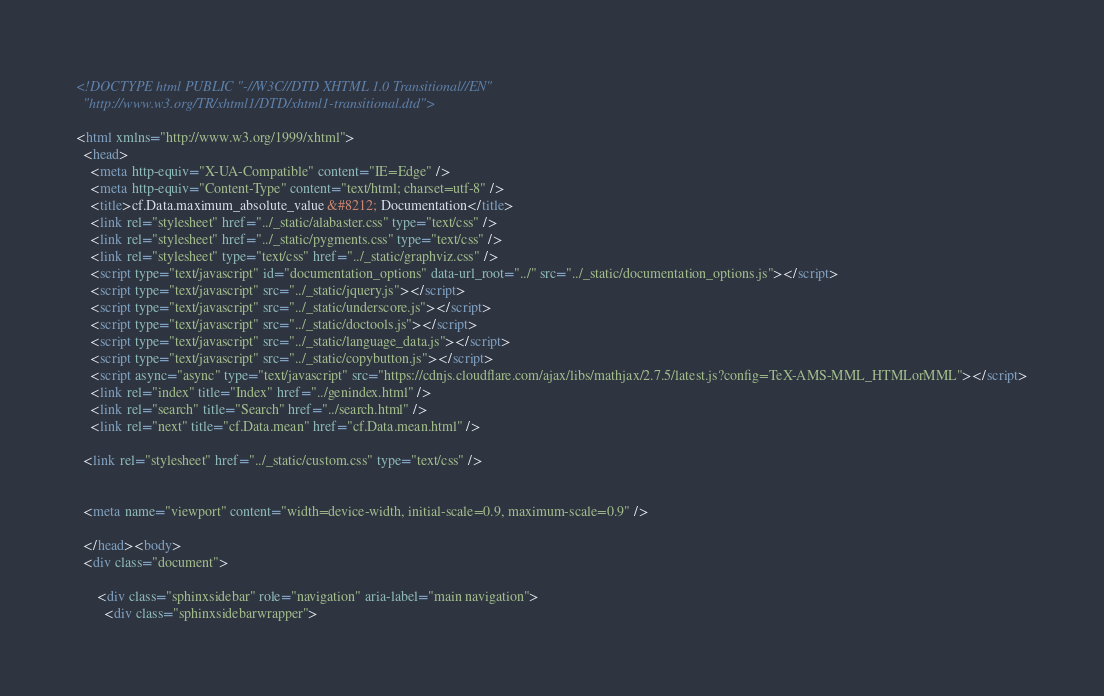Convert code to text. <code><loc_0><loc_0><loc_500><loc_500><_HTML_>
<!DOCTYPE html PUBLIC "-//W3C//DTD XHTML 1.0 Transitional//EN"
  "http://www.w3.org/TR/xhtml1/DTD/xhtml1-transitional.dtd">

<html xmlns="http://www.w3.org/1999/xhtml">
  <head>
    <meta http-equiv="X-UA-Compatible" content="IE=Edge" />
    <meta http-equiv="Content-Type" content="text/html; charset=utf-8" />
    <title>cf.Data.maximum_absolute_value &#8212; Documentation</title>
    <link rel="stylesheet" href="../_static/alabaster.css" type="text/css" />
    <link rel="stylesheet" href="../_static/pygments.css" type="text/css" />
    <link rel="stylesheet" type="text/css" href="../_static/graphviz.css" />
    <script type="text/javascript" id="documentation_options" data-url_root="../" src="../_static/documentation_options.js"></script>
    <script type="text/javascript" src="../_static/jquery.js"></script>
    <script type="text/javascript" src="../_static/underscore.js"></script>
    <script type="text/javascript" src="../_static/doctools.js"></script>
    <script type="text/javascript" src="../_static/language_data.js"></script>
    <script type="text/javascript" src="../_static/copybutton.js"></script>
    <script async="async" type="text/javascript" src="https://cdnjs.cloudflare.com/ajax/libs/mathjax/2.7.5/latest.js?config=TeX-AMS-MML_HTMLorMML"></script>
    <link rel="index" title="Index" href="../genindex.html" />
    <link rel="search" title="Search" href="../search.html" />
    <link rel="next" title="cf.Data.mean" href="cf.Data.mean.html" />
   
  <link rel="stylesheet" href="../_static/custom.css" type="text/css" />
  
  
  <meta name="viewport" content="width=device-width, initial-scale=0.9, maximum-scale=0.9" />

  </head><body>
  <div class="document">
    
      <div class="sphinxsidebar" role="navigation" aria-label="main navigation">
        <div class="sphinxsidebarwrapper"></code> 